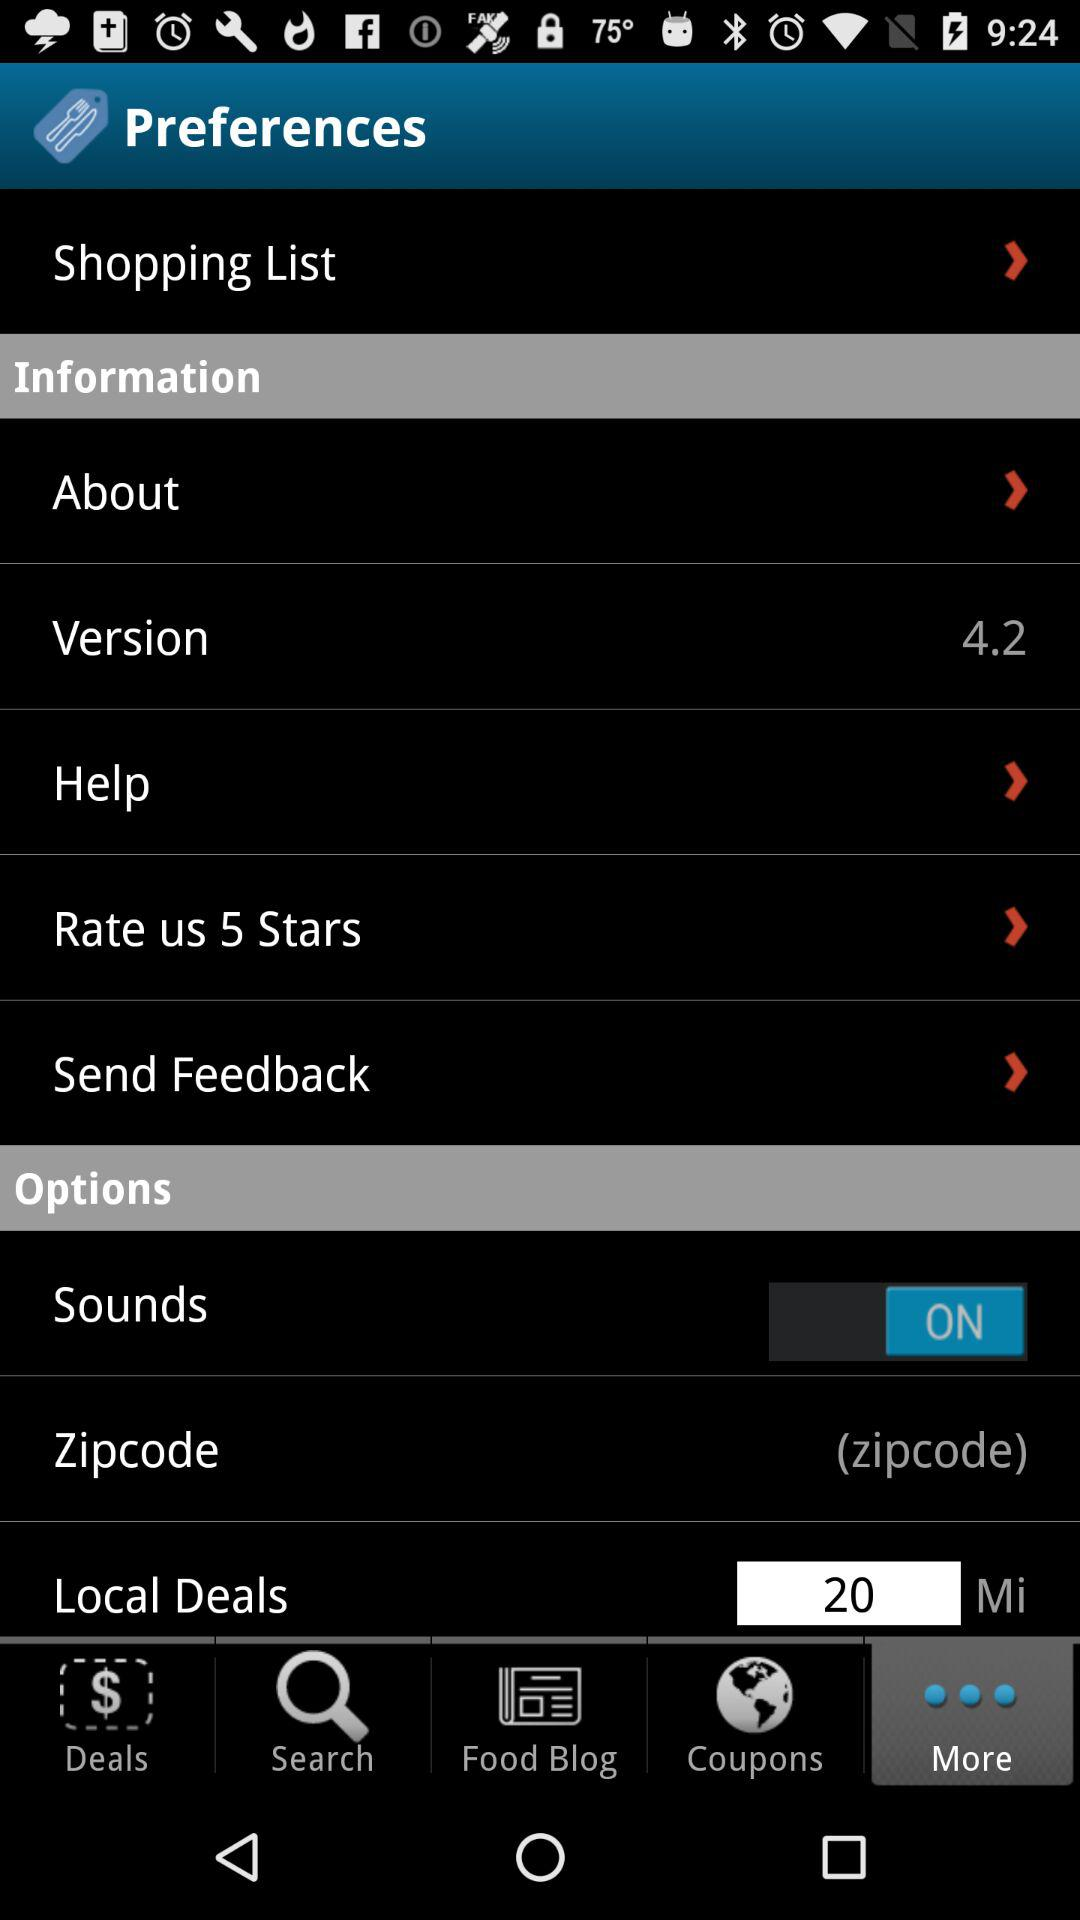What is the version of the application? The version is 4.2. 